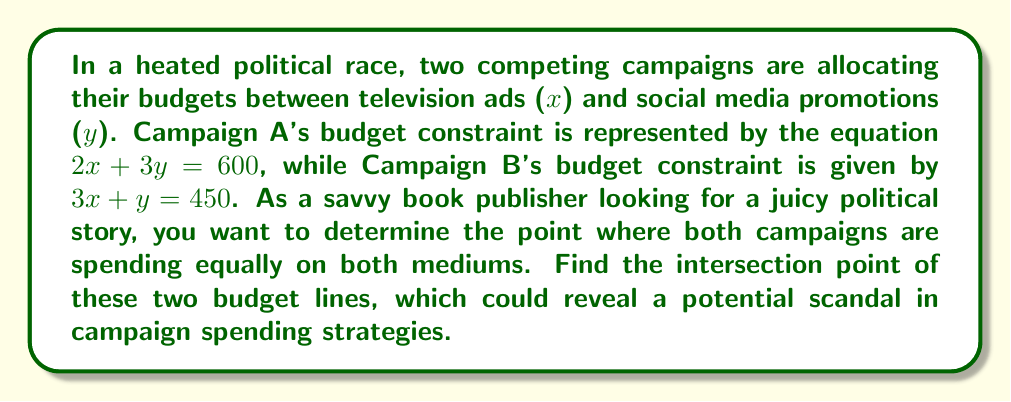What is the answer to this math problem? To find the point of intersection between the two campaign budget lines, we need to solve the system of linear equations:

$$\begin{cases}
2x + 3y = 600 \quad \text{(Campaign A)}\\
3x + y = 450 \quad \text{(Campaign B)}
\end{cases}$$

Let's solve this system using the substitution method:

1) From Campaign B's equation, express $y$ in terms of $x$:
   $y = 450 - 3x$

2) Substitute this expression for $y$ into Campaign A's equation:
   $2x + 3(450 - 3x) = 600$

3) Simplify:
   $2x + 1350 - 9x = 600$
   $-7x + 1350 = 600$

4) Solve for $x$:
   $-7x = -750$
   $x = \frac{750}{7} \approx 107.14$

5) Substitute this $x$ value back into either original equation to find $y$. Let's use Campaign B's equation:
   $3(107.14) + y = 450$
   $321.42 + y = 450$
   $y = 128.58$

Therefore, the point of intersection is approximately (107.14, 128.58).

This point represents the budget allocation where both campaigns are spending equally on TV ads and social media promotions.
Answer: The point of intersection is (107.14, 128.58), meaning both campaigns are spending $107,140 on TV ads and $128,580 on social media promotions at this point. 